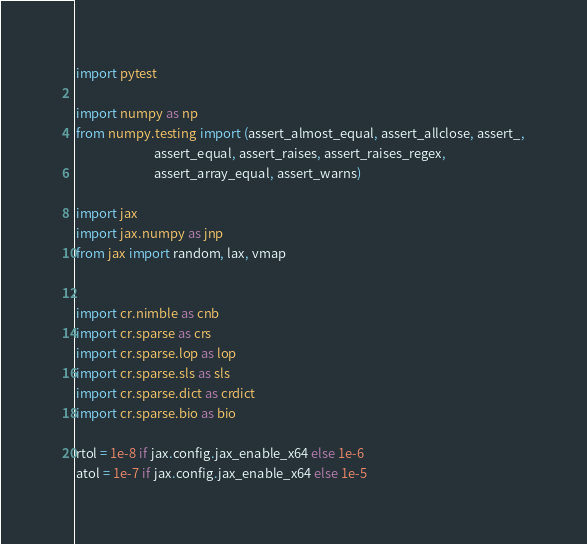Convert code to text. <code><loc_0><loc_0><loc_500><loc_500><_Python_>import pytest

import numpy as np
from numpy.testing import (assert_almost_equal, assert_allclose, assert_,
                           assert_equal, assert_raises, assert_raises_regex,
                           assert_array_equal, assert_warns)

import jax
import jax.numpy as jnp
from jax import random, lax, vmap


import cr.nimble as cnb
import cr.sparse as crs
import cr.sparse.lop as lop
import cr.sparse.sls as sls
import cr.sparse.dict as crdict
import cr.sparse.bio as bio

rtol = 1e-8 if jax.config.jax_enable_x64 else 1e-6
atol = 1e-7 if jax.config.jax_enable_x64 else 1e-5
</code> 